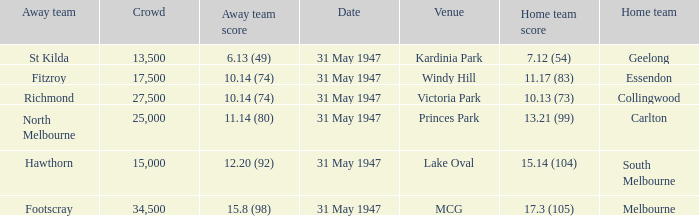What day is south melbourne at home? 31 May 1947. 